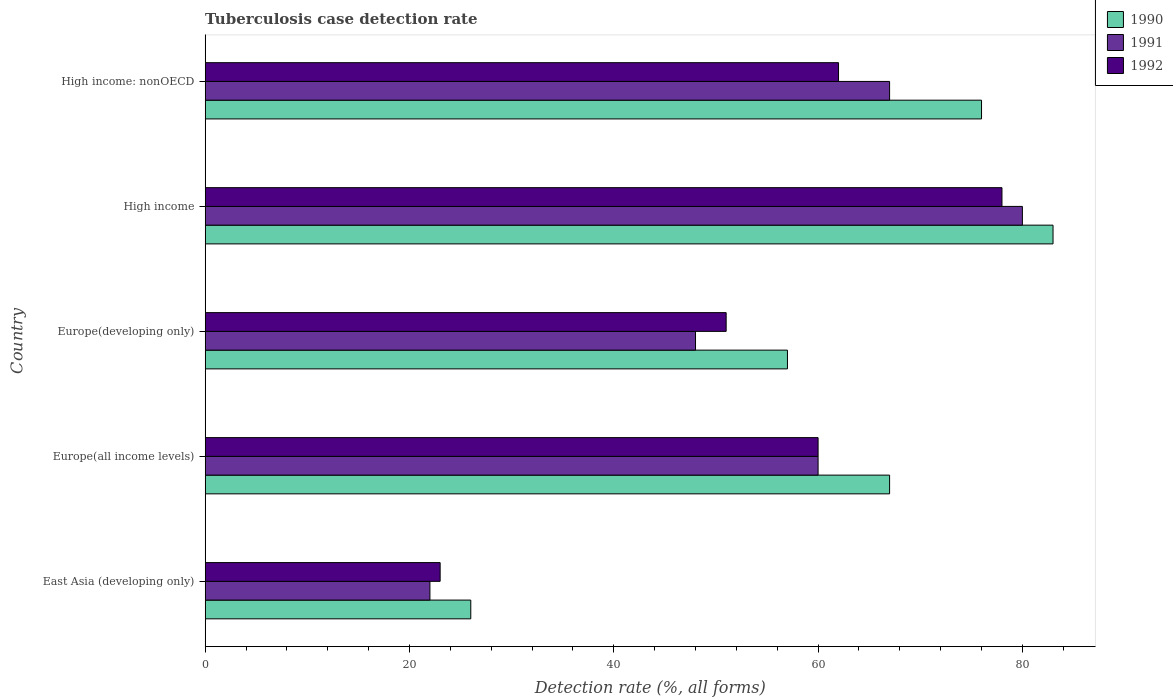How many different coloured bars are there?
Your answer should be compact. 3. How many groups of bars are there?
Give a very brief answer. 5. Are the number of bars on each tick of the Y-axis equal?
Your response must be concise. Yes. How many bars are there on the 2nd tick from the top?
Provide a short and direct response. 3. What is the label of the 2nd group of bars from the top?
Offer a very short reply. High income. Across all countries, what is the minimum tuberculosis case detection rate in in 1990?
Make the answer very short. 26. In which country was the tuberculosis case detection rate in in 1990 maximum?
Provide a succinct answer. High income. In which country was the tuberculosis case detection rate in in 1991 minimum?
Your response must be concise. East Asia (developing only). What is the total tuberculosis case detection rate in in 1992 in the graph?
Provide a succinct answer. 274. What is the difference between the tuberculosis case detection rate in in 1991 in Europe(developing only) and the tuberculosis case detection rate in in 1992 in East Asia (developing only)?
Give a very brief answer. 25. What is the average tuberculosis case detection rate in in 1990 per country?
Make the answer very short. 61.8. What is the difference between the tuberculosis case detection rate in in 1991 and tuberculosis case detection rate in in 1992 in East Asia (developing only)?
Offer a terse response. -1. In how many countries, is the tuberculosis case detection rate in in 1991 greater than 24 %?
Give a very brief answer. 4. What is the ratio of the tuberculosis case detection rate in in 1992 in Europe(all income levels) to that in High income: nonOECD?
Give a very brief answer. 0.97. Is the tuberculosis case detection rate in in 1992 in Europe(all income levels) less than that in High income?
Ensure brevity in your answer.  Yes. Is the sum of the tuberculosis case detection rate in in 1992 in East Asia (developing only) and Europe(developing only) greater than the maximum tuberculosis case detection rate in in 1991 across all countries?
Ensure brevity in your answer.  No. What does the 3rd bar from the top in East Asia (developing only) represents?
Your answer should be compact. 1990. What does the 2nd bar from the bottom in Europe(all income levels) represents?
Offer a very short reply. 1991. Is it the case that in every country, the sum of the tuberculosis case detection rate in in 1991 and tuberculosis case detection rate in in 1990 is greater than the tuberculosis case detection rate in in 1992?
Your answer should be very brief. Yes. What is the difference between two consecutive major ticks on the X-axis?
Make the answer very short. 20. Are the values on the major ticks of X-axis written in scientific E-notation?
Your answer should be very brief. No. Does the graph contain grids?
Your answer should be compact. No. Where does the legend appear in the graph?
Give a very brief answer. Top right. How many legend labels are there?
Give a very brief answer. 3. What is the title of the graph?
Give a very brief answer. Tuberculosis case detection rate. What is the label or title of the X-axis?
Offer a very short reply. Detection rate (%, all forms). What is the Detection rate (%, all forms) in 1991 in East Asia (developing only)?
Your response must be concise. 22. What is the Detection rate (%, all forms) of 1992 in East Asia (developing only)?
Make the answer very short. 23. What is the Detection rate (%, all forms) in 1990 in Europe(all income levels)?
Provide a short and direct response. 67. What is the Detection rate (%, all forms) of 1992 in Europe(all income levels)?
Your response must be concise. 60. What is the Detection rate (%, all forms) of 1992 in Europe(developing only)?
Make the answer very short. 51. What is the Detection rate (%, all forms) of 1991 in High income?
Your answer should be very brief. 80. What is the Detection rate (%, all forms) in 1992 in High income?
Provide a succinct answer. 78. What is the Detection rate (%, all forms) of 1991 in High income: nonOECD?
Your answer should be compact. 67. Across all countries, what is the maximum Detection rate (%, all forms) of 1991?
Offer a very short reply. 80. Across all countries, what is the maximum Detection rate (%, all forms) in 1992?
Your answer should be very brief. 78. Across all countries, what is the minimum Detection rate (%, all forms) in 1991?
Your answer should be compact. 22. What is the total Detection rate (%, all forms) in 1990 in the graph?
Offer a very short reply. 309. What is the total Detection rate (%, all forms) in 1991 in the graph?
Give a very brief answer. 277. What is the total Detection rate (%, all forms) in 1992 in the graph?
Make the answer very short. 274. What is the difference between the Detection rate (%, all forms) of 1990 in East Asia (developing only) and that in Europe(all income levels)?
Offer a terse response. -41. What is the difference between the Detection rate (%, all forms) of 1991 in East Asia (developing only) and that in Europe(all income levels)?
Ensure brevity in your answer.  -38. What is the difference between the Detection rate (%, all forms) in 1992 in East Asia (developing only) and that in Europe(all income levels)?
Provide a succinct answer. -37. What is the difference between the Detection rate (%, all forms) in 1990 in East Asia (developing only) and that in Europe(developing only)?
Make the answer very short. -31. What is the difference between the Detection rate (%, all forms) of 1991 in East Asia (developing only) and that in Europe(developing only)?
Make the answer very short. -26. What is the difference between the Detection rate (%, all forms) of 1990 in East Asia (developing only) and that in High income?
Your answer should be very brief. -57. What is the difference between the Detection rate (%, all forms) of 1991 in East Asia (developing only) and that in High income?
Your answer should be very brief. -58. What is the difference between the Detection rate (%, all forms) in 1992 in East Asia (developing only) and that in High income?
Your response must be concise. -55. What is the difference between the Detection rate (%, all forms) in 1990 in East Asia (developing only) and that in High income: nonOECD?
Your answer should be compact. -50. What is the difference between the Detection rate (%, all forms) of 1991 in East Asia (developing only) and that in High income: nonOECD?
Provide a succinct answer. -45. What is the difference between the Detection rate (%, all forms) in 1992 in East Asia (developing only) and that in High income: nonOECD?
Offer a terse response. -39. What is the difference between the Detection rate (%, all forms) in 1990 in Europe(all income levels) and that in Europe(developing only)?
Ensure brevity in your answer.  10. What is the difference between the Detection rate (%, all forms) of 1991 in Europe(all income levels) and that in Europe(developing only)?
Your answer should be compact. 12. What is the difference between the Detection rate (%, all forms) in 1992 in Europe(all income levels) and that in Europe(developing only)?
Your answer should be very brief. 9. What is the difference between the Detection rate (%, all forms) in 1990 in Europe(all income levels) and that in High income?
Keep it short and to the point. -16. What is the difference between the Detection rate (%, all forms) of 1991 in Europe(all income levels) and that in High income?
Your answer should be compact. -20. What is the difference between the Detection rate (%, all forms) in 1992 in Europe(all income levels) and that in High income?
Ensure brevity in your answer.  -18. What is the difference between the Detection rate (%, all forms) in 1991 in Europe(developing only) and that in High income?
Keep it short and to the point. -32. What is the difference between the Detection rate (%, all forms) of 1990 in High income and that in High income: nonOECD?
Provide a succinct answer. 7. What is the difference between the Detection rate (%, all forms) in 1991 in High income and that in High income: nonOECD?
Offer a very short reply. 13. What is the difference between the Detection rate (%, all forms) of 1992 in High income and that in High income: nonOECD?
Offer a very short reply. 16. What is the difference between the Detection rate (%, all forms) of 1990 in East Asia (developing only) and the Detection rate (%, all forms) of 1991 in Europe(all income levels)?
Keep it short and to the point. -34. What is the difference between the Detection rate (%, all forms) in 1990 in East Asia (developing only) and the Detection rate (%, all forms) in 1992 in Europe(all income levels)?
Make the answer very short. -34. What is the difference between the Detection rate (%, all forms) of 1991 in East Asia (developing only) and the Detection rate (%, all forms) of 1992 in Europe(all income levels)?
Your answer should be very brief. -38. What is the difference between the Detection rate (%, all forms) in 1990 in East Asia (developing only) and the Detection rate (%, all forms) in 1991 in High income?
Keep it short and to the point. -54. What is the difference between the Detection rate (%, all forms) in 1990 in East Asia (developing only) and the Detection rate (%, all forms) in 1992 in High income?
Provide a succinct answer. -52. What is the difference between the Detection rate (%, all forms) in 1991 in East Asia (developing only) and the Detection rate (%, all forms) in 1992 in High income?
Your response must be concise. -56. What is the difference between the Detection rate (%, all forms) in 1990 in East Asia (developing only) and the Detection rate (%, all forms) in 1991 in High income: nonOECD?
Provide a short and direct response. -41. What is the difference between the Detection rate (%, all forms) of 1990 in East Asia (developing only) and the Detection rate (%, all forms) of 1992 in High income: nonOECD?
Give a very brief answer. -36. What is the difference between the Detection rate (%, all forms) of 1991 in East Asia (developing only) and the Detection rate (%, all forms) of 1992 in High income: nonOECD?
Your answer should be very brief. -40. What is the difference between the Detection rate (%, all forms) of 1990 in Europe(all income levels) and the Detection rate (%, all forms) of 1992 in Europe(developing only)?
Provide a short and direct response. 16. What is the difference between the Detection rate (%, all forms) of 1991 in Europe(all income levels) and the Detection rate (%, all forms) of 1992 in Europe(developing only)?
Your answer should be compact. 9. What is the difference between the Detection rate (%, all forms) of 1990 in Europe(all income levels) and the Detection rate (%, all forms) of 1992 in High income: nonOECD?
Your answer should be compact. 5. What is the difference between the Detection rate (%, all forms) of 1991 in Europe(all income levels) and the Detection rate (%, all forms) of 1992 in High income: nonOECD?
Keep it short and to the point. -2. What is the difference between the Detection rate (%, all forms) of 1990 in Europe(developing only) and the Detection rate (%, all forms) of 1991 in High income?
Ensure brevity in your answer.  -23. What is the difference between the Detection rate (%, all forms) in 1990 in Europe(developing only) and the Detection rate (%, all forms) in 1992 in High income?
Your answer should be compact. -21. What is the difference between the Detection rate (%, all forms) in 1991 in Europe(developing only) and the Detection rate (%, all forms) in 1992 in High income?
Keep it short and to the point. -30. What is the difference between the Detection rate (%, all forms) of 1990 in High income and the Detection rate (%, all forms) of 1991 in High income: nonOECD?
Your answer should be compact. 16. What is the difference between the Detection rate (%, all forms) in 1990 in High income and the Detection rate (%, all forms) in 1992 in High income: nonOECD?
Keep it short and to the point. 21. What is the difference between the Detection rate (%, all forms) in 1991 in High income and the Detection rate (%, all forms) in 1992 in High income: nonOECD?
Your answer should be very brief. 18. What is the average Detection rate (%, all forms) in 1990 per country?
Offer a terse response. 61.8. What is the average Detection rate (%, all forms) in 1991 per country?
Make the answer very short. 55.4. What is the average Detection rate (%, all forms) of 1992 per country?
Offer a very short reply. 54.8. What is the difference between the Detection rate (%, all forms) in 1990 and Detection rate (%, all forms) in 1991 in East Asia (developing only)?
Provide a succinct answer. 4. What is the difference between the Detection rate (%, all forms) of 1990 and Detection rate (%, all forms) of 1992 in East Asia (developing only)?
Your response must be concise. 3. What is the difference between the Detection rate (%, all forms) in 1990 and Detection rate (%, all forms) in 1991 in Europe(all income levels)?
Your answer should be compact. 7. What is the difference between the Detection rate (%, all forms) of 1990 and Detection rate (%, all forms) of 1992 in Europe(all income levels)?
Keep it short and to the point. 7. What is the difference between the Detection rate (%, all forms) of 1991 and Detection rate (%, all forms) of 1992 in Europe(all income levels)?
Your response must be concise. 0. What is the difference between the Detection rate (%, all forms) in 1991 and Detection rate (%, all forms) in 1992 in Europe(developing only)?
Ensure brevity in your answer.  -3. What is the difference between the Detection rate (%, all forms) in 1990 and Detection rate (%, all forms) in 1991 in High income?
Your answer should be compact. 3. What is the difference between the Detection rate (%, all forms) in 1991 and Detection rate (%, all forms) in 1992 in High income?
Your response must be concise. 2. What is the difference between the Detection rate (%, all forms) of 1990 and Detection rate (%, all forms) of 1992 in High income: nonOECD?
Keep it short and to the point. 14. What is the difference between the Detection rate (%, all forms) in 1991 and Detection rate (%, all forms) in 1992 in High income: nonOECD?
Offer a very short reply. 5. What is the ratio of the Detection rate (%, all forms) in 1990 in East Asia (developing only) to that in Europe(all income levels)?
Ensure brevity in your answer.  0.39. What is the ratio of the Detection rate (%, all forms) in 1991 in East Asia (developing only) to that in Europe(all income levels)?
Your answer should be compact. 0.37. What is the ratio of the Detection rate (%, all forms) of 1992 in East Asia (developing only) to that in Europe(all income levels)?
Keep it short and to the point. 0.38. What is the ratio of the Detection rate (%, all forms) of 1990 in East Asia (developing only) to that in Europe(developing only)?
Offer a terse response. 0.46. What is the ratio of the Detection rate (%, all forms) in 1991 in East Asia (developing only) to that in Europe(developing only)?
Give a very brief answer. 0.46. What is the ratio of the Detection rate (%, all forms) in 1992 in East Asia (developing only) to that in Europe(developing only)?
Provide a succinct answer. 0.45. What is the ratio of the Detection rate (%, all forms) in 1990 in East Asia (developing only) to that in High income?
Offer a terse response. 0.31. What is the ratio of the Detection rate (%, all forms) of 1991 in East Asia (developing only) to that in High income?
Give a very brief answer. 0.28. What is the ratio of the Detection rate (%, all forms) of 1992 in East Asia (developing only) to that in High income?
Offer a terse response. 0.29. What is the ratio of the Detection rate (%, all forms) in 1990 in East Asia (developing only) to that in High income: nonOECD?
Your response must be concise. 0.34. What is the ratio of the Detection rate (%, all forms) in 1991 in East Asia (developing only) to that in High income: nonOECD?
Your answer should be compact. 0.33. What is the ratio of the Detection rate (%, all forms) in 1992 in East Asia (developing only) to that in High income: nonOECD?
Your answer should be very brief. 0.37. What is the ratio of the Detection rate (%, all forms) of 1990 in Europe(all income levels) to that in Europe(developing only)?
Ensure brevity in your answer.  1.18. What is the ratio of the Detection rate (%, all forms) in 1992 in Europe(all income levels) to that in Europe(developing only)?
Give a very brief answer. 1.18. What is the ratio of the Detection rate (%, all forms) of 1990 in Europe(all income levels) to that in High income?
Give a very brief answer. 0.81. What is the ratio of the Detection rate (%, all forms) in 1992 in Europe(all income levels) to that in High income?
Make the answer very short. 0.77. What is the ratio of the Detection rate (%, all forms) of 1990 in Europe(all income levels) to that in High income: nonOECD?
Provide a succinct answer. 0.88. What is the ratio of the Detection rate (%, all forms) in 1991 in Europe(all income levels) to that in High income: nonOECD?
Your response must be concise. 0.9. What is the ratio of the Detection rate (%, all forms) in 1990 in Europe(developing only) to that in High income?
Offer a terse response. 0.69. What is the ratio of the Detection rate (%, all forms) of 1992 in Europe(developing only) to that in High income?
Offer a very short reply. 0.65. What is the ratio of the Detection rate (%, all forms) in 1990 in Europe(developing only) to that in High income: nonOECD?
Offer a very short reply. 0.75. What is the ratio of the Detection rate (%, all forms) of 1991 in Europe(developing only) to that in High income: nonOECD?
Your answer should be compact. 0.72. What is the ratio of the Detection rate (%, all forms) in 1992 in Europe(developing only) to that in High income: nonOECD?
Ensure brevity in your answer.  0.82. What is the ratio of the Detection rate (%, all forms) of 1990 in High income to that in High income: nonOECD?
Make the answer very short. 1.09. What is the ratio of the Detection rate (%, all forms) in 1991 in High income to that in High income: nonOECD?
Your answer should be very brief. 1.19. What is the ratio of the Detection rate (%, all forms) of 1992 in High income to that in High income: nonOECD?
Ensure brevity in your answer.  1.26. What is the difference between the highest and the second highest Detection rate (%, all forms) of 1990?
Your answer should be very brief. 7. What is the difference between the highest and the lowest Detection rate (%, all forms) of 1991?
Your response must be concise. 58. What is the difference between the highest and the lowest Detection rate (%, all forms) in 1992?
Give a very brief answer. 55. 